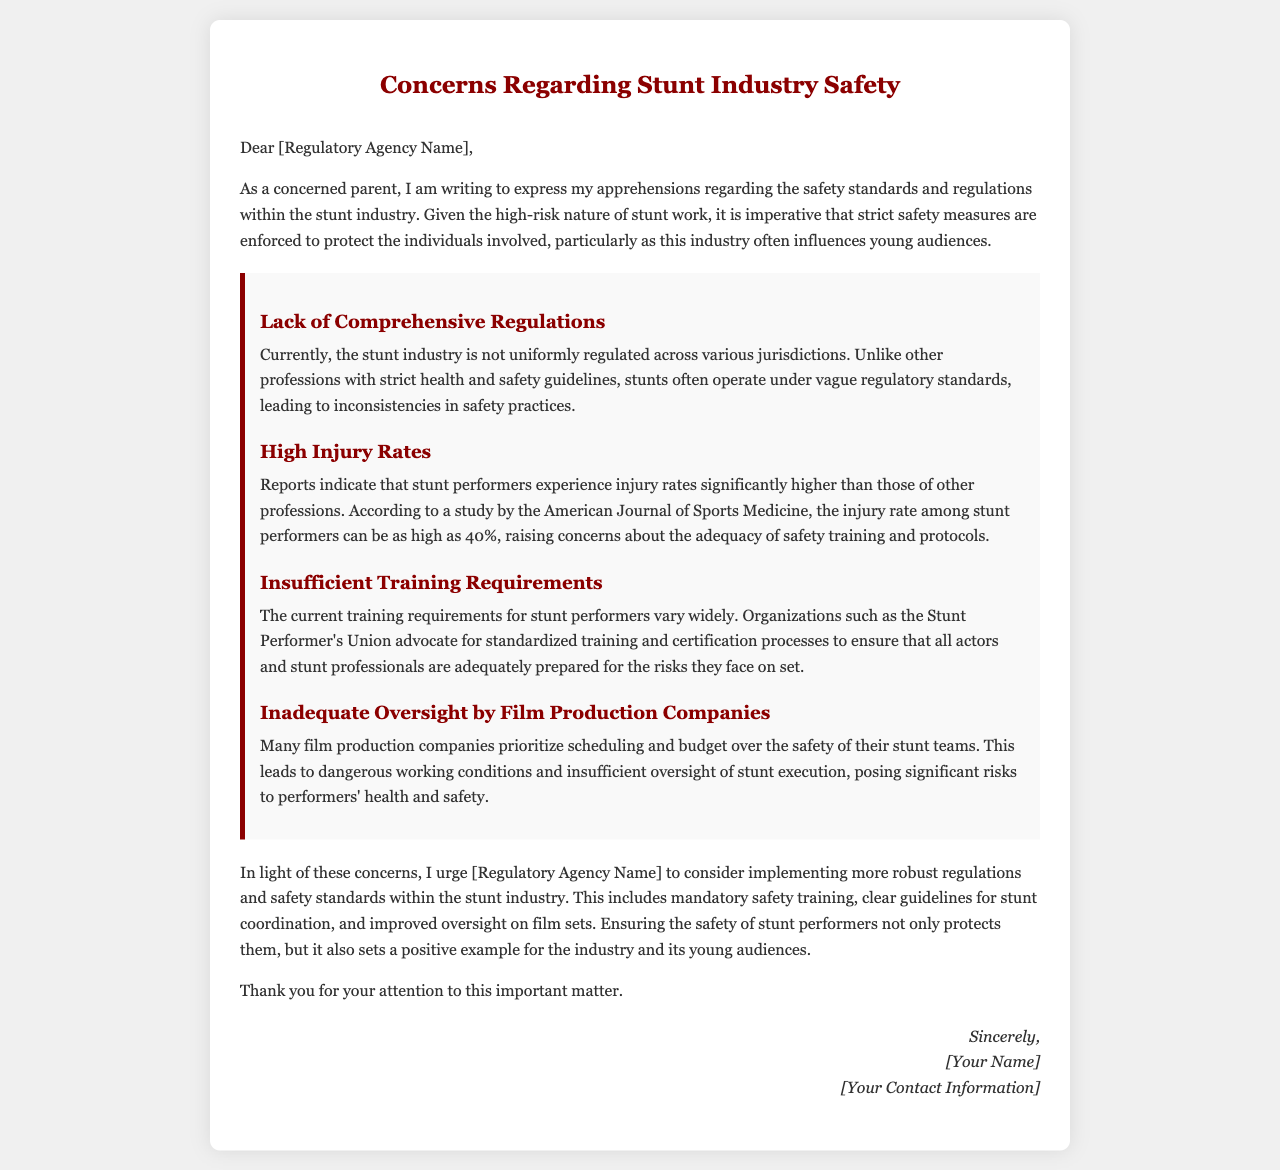What is the title of the letter? The title of the letter is located at the top of the document within the heading.
Answer: Concerns Regarding Stunt Industry Safety What profession's injury rates are compared to stunt performers? The comparison of injury rates is made against other professions in the document.
Answer: Other professions What percentage can the injury rate among stunt performers be as high as? The letter specifies a particular statistic regarding injury rates in the stunt industry.
Answer: 40% What organization advocates for standardized training for stunt performers? The document mentions an organization promoting better training standards for stunt performers.
Answer: Stunt Performer's Union What is lacking in the oversight by film production companies according to the document? The letter discusses the quality of oversight related to safety in film production.
Answer: Adequate oversight What does the letter urge the regulatory agency to implement? The main call to action in the letter highlights a request for specific measures to be taken.
Answer: More robust regulations and safety standards Who is the signatory of the letter indicated as? The closing section of the letter includes the signatory information.
Answer: [Your Name] What is the primary concern expressed in the letter? The essence of the letter revolves around a specific concern related to the stunt industry.
Answer: Safety standards and regulations 